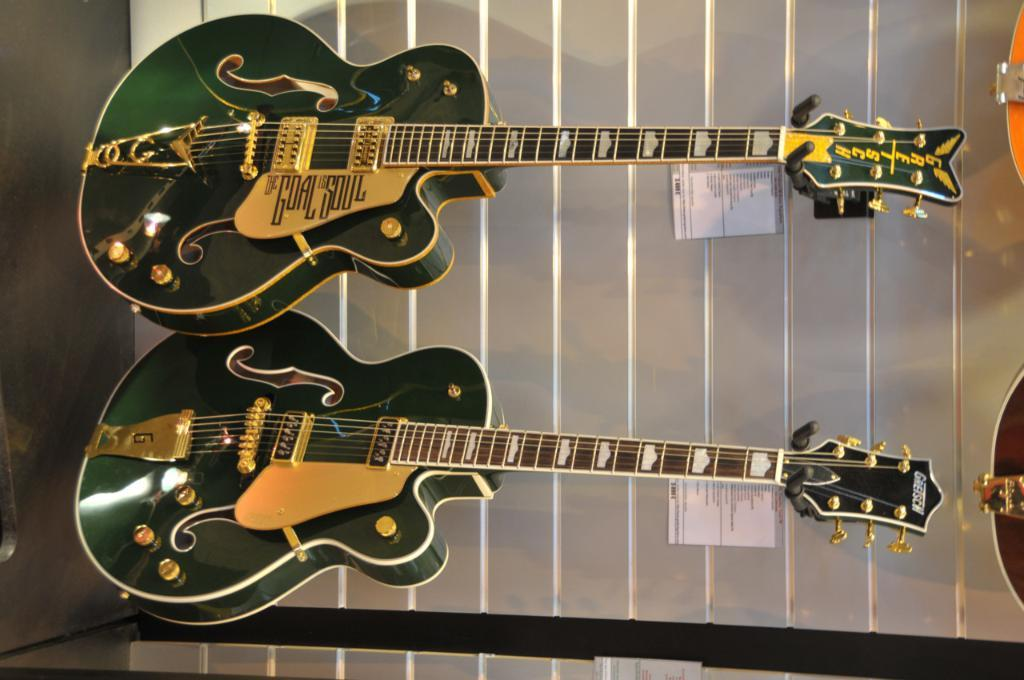How many guitars are present in the image? There are 2 guitars in the image. What are the colors of the guitars? One guitar is green in color, and the other guitar is gold in color. What type of silk is used to make the strings of the guitars in the image? There is no mention of silk or strings in the provided facts, and therefore it cannot be determined from the image. 